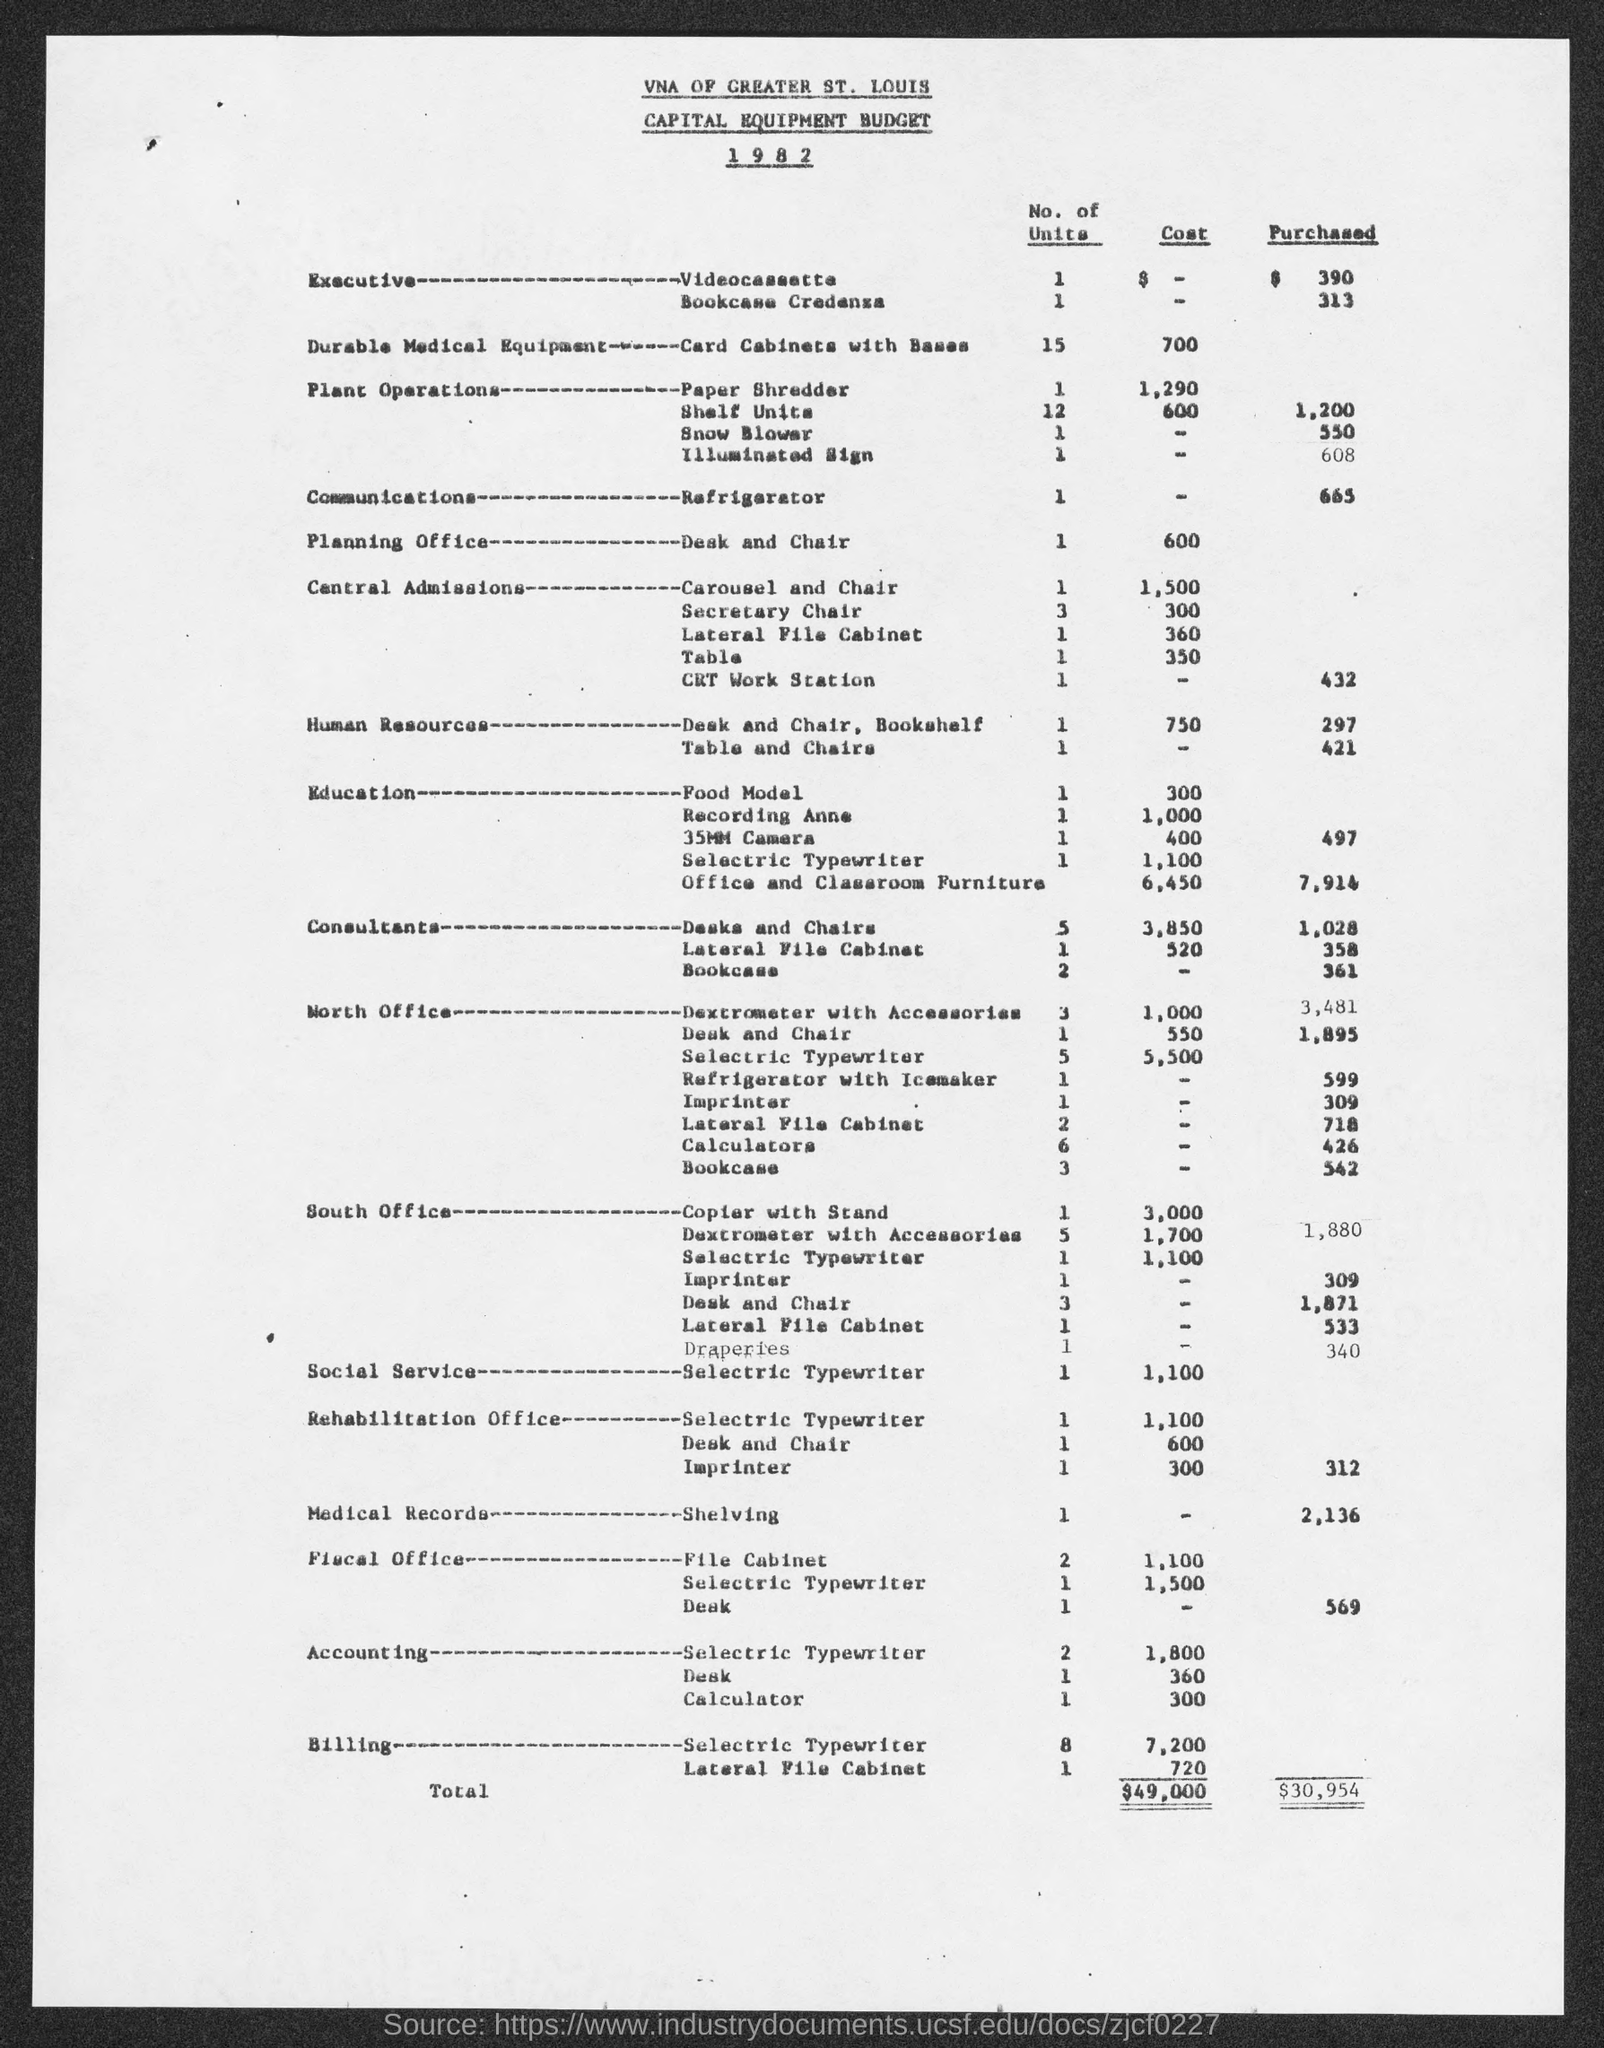Point out several critical features in this image. The budget was for the year 1982. The document pertains to a capital equipment budget. 